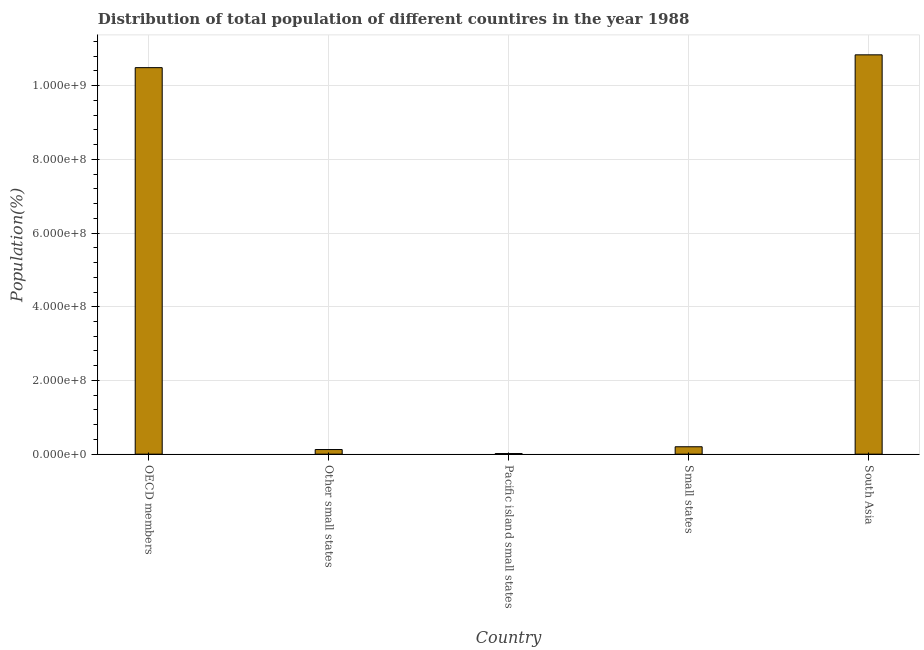Does the graph contain any zero values?
Your response must be concise. No. What is the title of the graph?
Provide a succinct answer. Distribution of total population of different countires in the year 1988. What is the label or title of the X-axis?
Your answer should be compact. Country. What is the label or title of the Y-axis?
Keep it short and to the point. Population(%). What is the population in OECD members?
Your response must be concise. 1.05e+09. Across all countries, what is the maximum population?
Provide a short and direct response. 1.08e+09. Across all countries, what is the minimum population?
Provide a short and direct response. 1.64e+06. In which country was the population minimum?
Keep it short and to the point. Pacific island small states. What is the sum of the population?
Ensure brevity in your answer.  2.17e+09. What is the difference between the population in Small states and South Asia?
Ensure brevity in your answer.  -1.06e+09. What is the average population per country?
Your answer should be very brief. 4.33e+08. What is the median population?
Make the answer very short. 2.01e+07. What is the ratio of the population in Small states to that in South Asia?
Offer a very short reply. 0.02. What is the difference between the highest and the second highest population?
Provide a succinct answer. 3.47e+07. What is the difference between the highest and the lowest population?
Make the answer very short. 1.08e+09. In how many countries, is the population greater than the average population taken over all countries?
Provide a short and direct response. 2. How many bars are there?
Your answer should be very brief. 5. Are the values on the major ticks of Y-axis written in scientific E-notation?
Provide a short and direct response. Yes. What is the Population(%) of OECD members?
Give a very brief answer. 1.05e+09. What is the Population(%) in Other small states?
Ensure brevity in your answer.  1.26e+07. What is the Population(%) in Pacific island small states?
Your answer should be very brief. 1.64e+06. What is the Population(%) in Small states?
Ensure brevity in your answer.  2.01e+07. What is the Population(%) in South Asia?
Make the answer very short. 1.08e+09. What is the difference between the Population(%) in OECD members and Other small states?
Provide a short and direct response. 1.04e+09. What is the difference between the Population(%) in OECD members and Pacific island small states?
Ensure brevity in your answer.  1.05e+09. What is the difference between the Population(%) in OECD members and Small states?
Offer a terse response. 1.03e+09. What is the difference between the Population(%) in OECD members and South Asia?
Give a very brief answer. -3.47e+07. What is the difference between the Population(%) in Other small states and Pacific island small states?
Your answer should be very brief. 1.09e+07. What is the difference between the Population(%) in Other small states and Small states?
Your answer should be compact. -7.53e+06. What is the difference between the Population(%) in Other small states and South Asia?
Your answer should be very brief. -1.07e+09. What is the difference between the Population(%) in Pacific island small states and Small states?
Make the answer very short. -1.84e+07. What is the difference between the Population(%) in Pacific island small states and South Asia?
Provide a succinct answer. -1.08e+09. What is the difference between the Population(%) in Small states and South Asia?
Your response must be concise. -1.06e+09. What is the ratio of the Population(%) in OECD members to that in Other small states?
Keep it short and to the point. 83.55. What is the ratio of the Population(%) in OECD members to that in Pacific island small states?
Give a very brief answer. 638.87. What is the ratio of the Population(%) in OECD members to that in Small states?
Make the answer very short. 52.23. What is the ratio of the Population(%) in OECD members to that in South Asia?
Offer a very short reply. 0.97. What is the ratio of the Population(%) in Other small states to that in Pacific island small states?
Offer a terse response. 7.65. What is the ratio of the Population(%) in Other small states to that in South Asia?
Your answer should be compact. 0.01. What is the ratio of the Population(%) in Pacific island small states to that in Small states?
Make the answer very short. 0.08. What is the ratio of the Population(%) in Pacific island small states to that in South Asia?
Offer a terse response. 0. What is the ratio of the Population(%) in Small states to that in South Asia?
Provide a succinct answer. 0.02. 